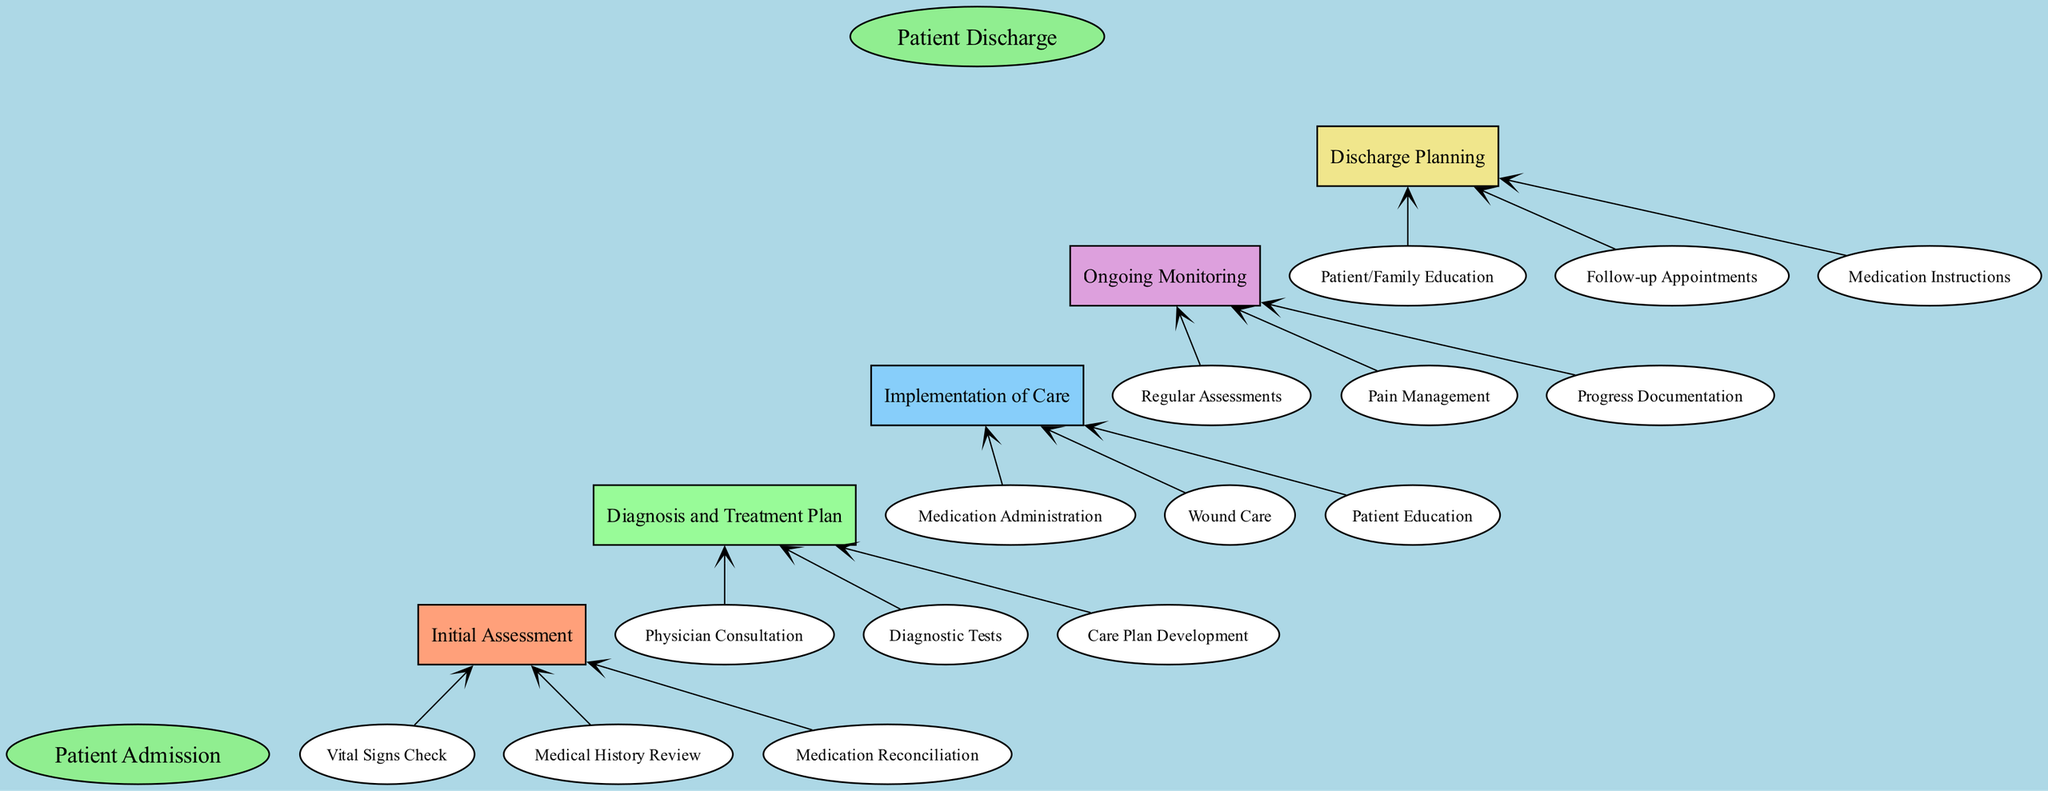What is the starting point of the patient care process? The diagram shows "Patient Admission" as the starting point, indicated as the first node at the top.
Answer: Patient Admission How many main elements are there in the care process? By counting the distinct sections, there are five main elements leading from the start to the discharge, each representing a stage in patient care.
Answer: 5 What is the final stage of the patient care process? The diagram concludes with "Patient Discharge" as the last node, marking the end of the care process.
Answer: Patient Discharge Which element directly follows "Initial Assessment"? Looking at the flow from the diagram, "Diagnosis and Treatment Plan" comes directly after "Initial Assessment" in the sequence of steps.
Answer: Diagnosis and Treatment Plan What type of care is provided during the "Implementation of Care" element? Within this element, care actions listed include "Medication Administration," "Wound Care," and "Patient Education," which indicate the practical steps taken to implement the care plan.
Answer: Medication Administration, Wound Care, Patient Education How many child nodes are associated with "Ongoing Monitoring"? According to the diagram, "Ongoing Monitoring" comprises three child nodes: "Regular Assessments," "Pain Management," and "Progress Documentation." Thus, there are three child nodes.
Answer: 3 Which child node is related to the last element before discharge? "Discharge Planning" is the last main element before discharge, and its child nodes include "Patient/Family Education," "Follow-up Appointments," and "Medication Instructions," so any of these child nodes relate directly to discharge.
Answer: Patient/Family Education, Follow-up Appointments, Medication Instructions What are the three child nodes under "Diagnosis and Treatment Plan"? The diagram details three specific tasks under "Diagnosis and Treatment Plan," which include "Physician Consultation," "Diagnostic Tests," and "Care Plan Development."
Answer: Physician Consultation, Diagnostic Tests, Care Plan Development How is the flow from "Initial Assessment" to "Patient Discharge" visually represented? The flow is represented with arrows connecting each stage, demonstrating the sequence from "Initial Assessment" through subsequent elements to ultimately reach "Patient Discharge."
Answer: With arrows 